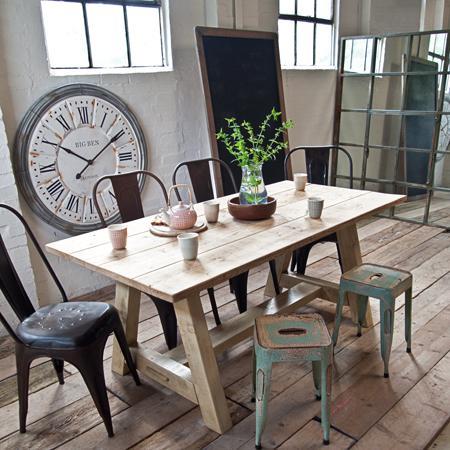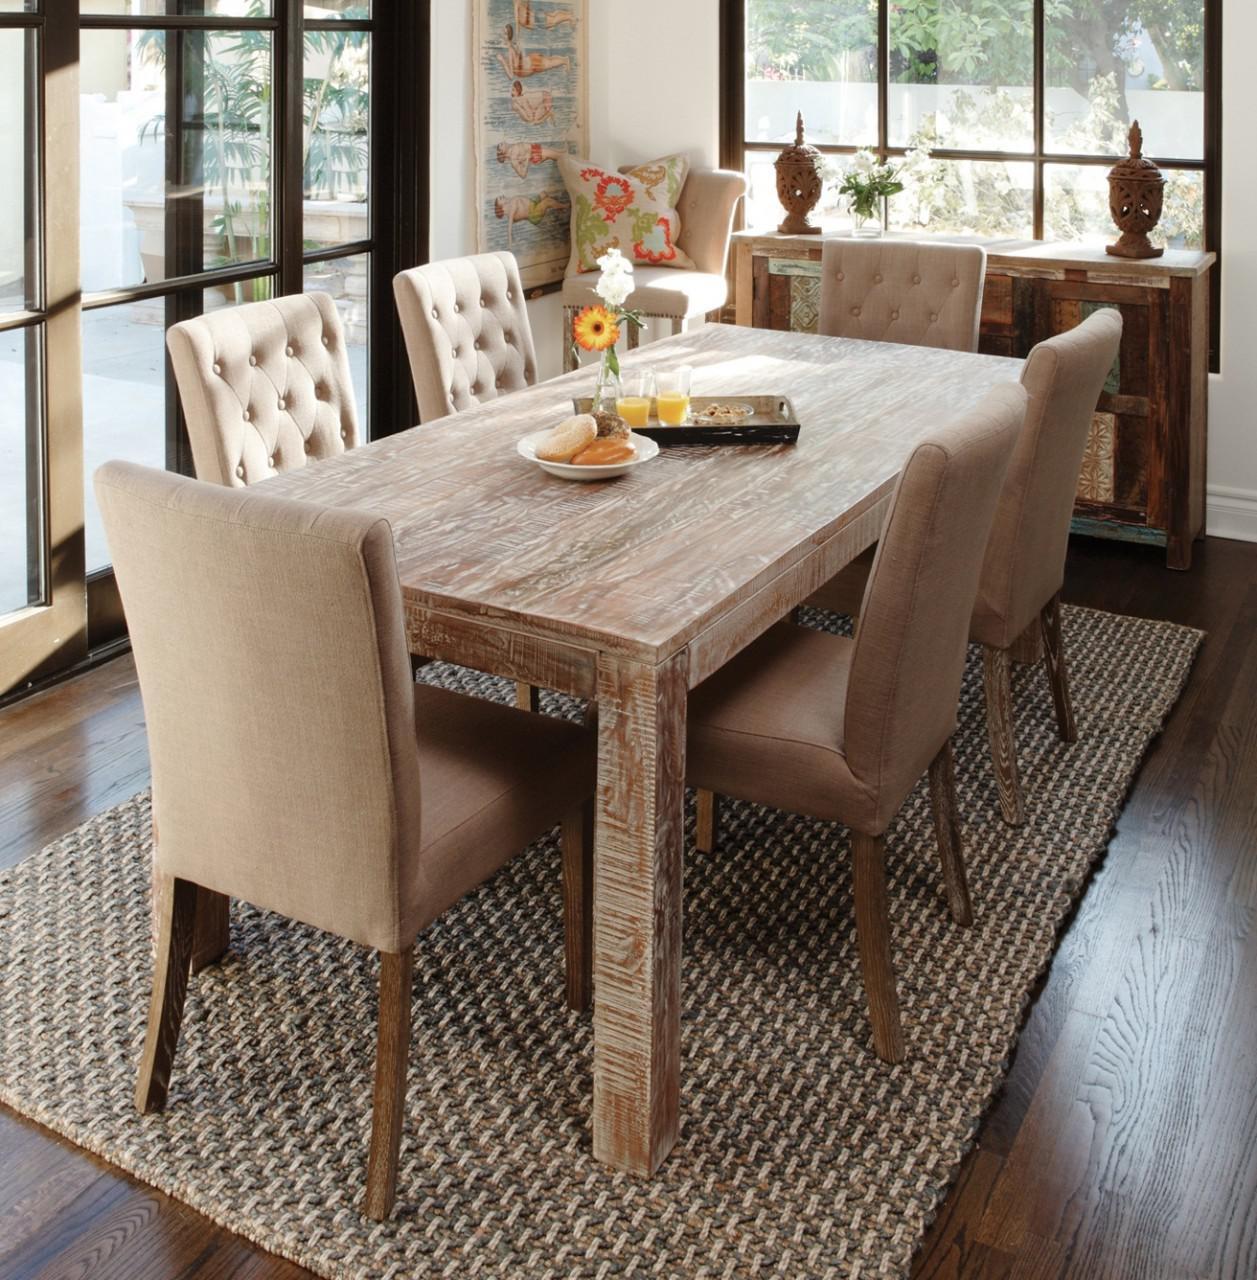The first image is the image on the left, the second image is the image on the right. Assess this claim about the two images: "There are at least two frames on the wall.". Correct or not? Answer yes or no. No. 